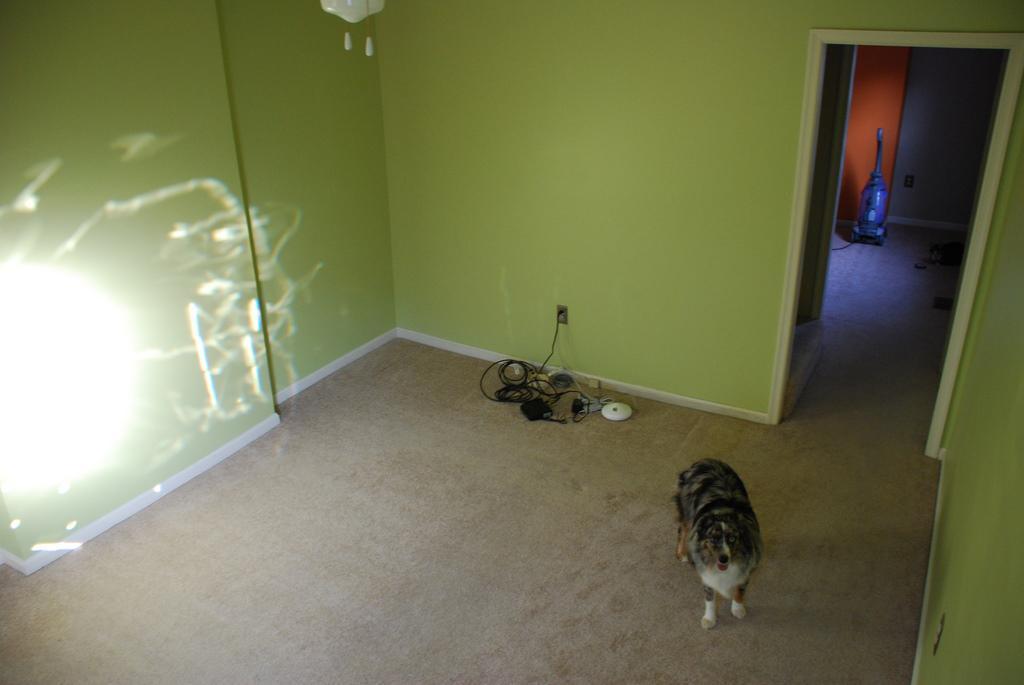Could you give a brief overview of what you see in this image? In this image we can see a dog. At the bottom of the image there is carpet. In the background of the image there is wall. To the right side of the image there is a door. 